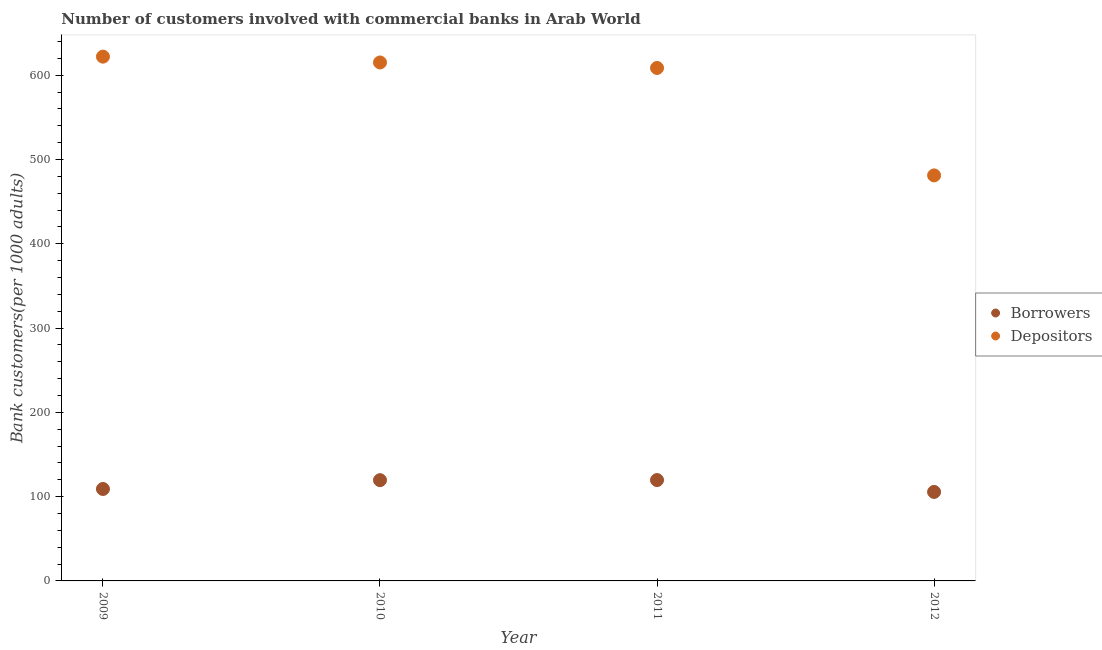Is the number of dotlines equal to the number of legend labels?
Ensure brevity in your answer.  Yes. What is the number of depositors in 2011?
Ensure brevity in your answer.  608.64. Across all years, what is the maximum number of borrowers?
Keep it short and to the point. 119.68. Across all years, what is the minimum number of borrowers?
Offer a terse response. 105.58. In which year was the number of borrowers maximum?
Provide a succinct answer. 2011. In which year was the number of borrowers minimum?
Make the answer very short. 2012. What is the total number of depositors in the graph?
Your answer should be compact. 2327.04. What is the difference between the number of depositors in 2011 and that in 2012?
Offer a terse response. 127.47. What is the difference between the number of depositors in 2012 and the number of borrowers in 2009?
Offer a terse response. 372.07. What is the average number of depositors per year?
Make the answer very short. 581.76. In the year 2009, what is the difference between the number of borrowers and number of depositors?
Provide a succinct answer. -512.98. What is the ratio of the number of depositors in 2011 to that in 2012?
Keep it short and to the point. 1.26. Is the difference between the number of borrowers in 2010 and 2012 greater than the difference between the number of depositors in 2010 and 2012?
Offer a terse response. No. What is the difference between the highest and the second highest number of depositors?
Your answer should be compact. 6.92. What is the difference between the highest and the lowest number of depositors?
Make the answer very short. 140.91. Does the number of borrowers monotonically increase over the years?
Ensure brevity in your answer.  No. Is the number of borrowers strictly greater than the number of depositors over the years?
Keep it short and to the point. No. Is the number of depositors strictly less than the number of borrowers over the years?
Your answer should be very brief. No. How many dotlines are there?
Provide a short and direct response. 2. How many years are there in the graph?
Your answer should be very brief. 4. What is the difference between two consecutive major ticks on the Y-axis?
Ensure brevity in your answer.  100. Does the graph contain any zero values?
Provide a succinct answer. No. How many legend labels are there?
Provide a short and direct response. 2. How are the legend labels stacked?
Ensure brevity in your answer.  Vertical. What is the title of the graph?
Make the answer very short. Number of customers involved with commercial banks in Arab World. Does "Non-resident workers" appear as one of the legend labels in the graph?
Keep it short and to the point. No. What is the label or title of the Y-axis?
Keep it short and to the point. Bank customers(per 1000 adults). What is the Bank customers(per 1000 adults) of Borrowers in 2009?
Provide a succinct answer. 109.1. What is the Bank customers(per 1000 adults) in Depositors in 2009?
Your answer should be compact. 622.08. What is the Bank customers(per 1000 adults) of Borrowers in 2010?
Give a very brief answer. 119.55. What is the Bank customers(per 1000 adults) in Depositors in 2010?
Provide a short and direct response. 615.16. What is the Bank customers(per 1000 adults) in Borrowers in 2011?
Keep it short and to the point. 119.68. What is the Bank customers(per 1000 adults) in Depositors in 2011?
Make the answer very short. 608.64. What is the Bank customers(per 1000 adults) of Borrowers in 2012?
Offer a very short reply. 105.58. What is the Bank customers(per 1000 adults) of Depositors in 2012?
Provide a short and direct response. 481.17. Across all years, what is the maximum Bank customers(per 1000 adults) of Borrowers?
Give a very brief answer. 119.68. Across all years, what is the maximum Bank customers(per 1000 adults) in Depositors?
Offer a terse response. 622.08. Across all years, what is the minimum Bank customers(per 1000 adults) of Borrowers?
Make the answer very short. 105.58. Across all years, what is the minimum Bank customers(per 1000 adults) in Depositors?
Make the answer very short. 481.17. What is the total Bank customers(per 1000 adults) in Borrowers in the graph?
Provide a short and direct response. 453.91. What is the total Bank customers(per 1000 adults) in Depositors in the graph?
Provide a short and direct response. 2327.04. What is the difference between the Bank customers(per 1000 adults) in Borrowers in 2009 and that in 2010?
Keep it short and to the point. -10.45. What is the difference between the Bank customers(per 1000 adults) of Depositors in 2009 and that in 2010?
Make the answer very short. 6.92. What is the difference between the Bank customers(per 1000 adults) of Borrowers in 2009 and that in 2011?
Ensure brevity in your answer.  -10.58. What is the difference between the Bank customers(per 1000 adults) of Depositors in 2009 and that in 2011?
Provide a short and direct response. 13.44. What is the difference between the Bank customers(per 1000 adults) in Borrowers in 2009 and that in 2012?
Your response must be concise. 3.52. What is the difference between the Bank customers(per 1000 adults) in Depositors in 2009 and that in 2012?
Ensure brevity in your answer.  140.91. What is the difference between the Bank customers(per 1000 adults) of Borrowers in 2010 and that in 2011?
Provide a short and direct response. -0.13. What is the difference between the Bank customers(per 1000 adults) of Depositors in 2010 and that in 2011?
Offer a very short reply. 6.52. What is the difference between the Bank customers(per 1000 adults) of Borrowers in 2010 and that in 2012?
Offer a very short reply. 13.97. What is the difference between the Bank customers(per 1000 adults) of Depositors in 2010 and that in 2012?
Ensure brevity in your answer.  133.99. What is the difference between the Bank customers(per 1000 adults) of Borrowers in 2011 and that in 2012?
Provide a succinct answer. 14.1. What is the difference between the Bank customers(per 1000 adults) of Depositors in 2011 and that in 2012?
Provide a succinct answer. 127.47. What is the difference between the Bank customers(per 1000 adults) in Borrowers in 2009 and the Bank customers(per 1000 adults) in Depositors in 2010?
Provide a short and direct response. -506.06. What is the difference between the Bank customers(per 1000 adults) of Borrowers in 2009 and the Bank customers(per 1000 adults) of Depositors in 2011?
Provide a short and direct response. -499.54. What is the difference between the Bank customers(per 1000 adults) of Borrowers in 2009 and the Bank customers(per 1000 adults) of Depositors in 2012?
Ensure brevity in your answer.  -372.07. What is the difference between the Bank customers(per 1000 adults) in Borrowers in 2010 and the Bank customers(per 1000 adults) in Depositors in 2011?
Provide a short and direct response. -489.09. What is the difference between the Bank customers(per 1000 adults) in Borrowers in 2010 and the Bank customers(per 1000 adults) in Depositors in 2012?
Give a very brief answer. -361.62. What is the difference between the Bank customers(per 1000 adults) of Borrowers in 2011 and the Bank customers(per 1000 adults) of Depositors in 2012?
Make the answer very short. -361.49. What is the average Bank customers(per 1000 adults) of Borrowers per year?
Offer a terse response. 113.48. What is the average Bank customers(per 1000 adults) of Depositors per year?
Offer a very short reply. 581.76. In the year 2009, what is the difference between the Bank customers(per 1000 adults) of Borrowers and Bank customers(per 1000 adults) of Depositors?
Keep it short and to the point. -512.98. In the year 2010, what is the difference between the Bank customers(per 1000 adults) in Borrowers and Bank customers(per 1000 adults) in Depositors?
Make the answer very short. -495.61. In the year 2011, what is the difference between the Bank customers(per 1000 adults) in Borrowers and Bank customers(per 1000 adults) in Depositors?
Provide a succinct answer. -488.96. In the year 2012, what is the difference between the Bank customers(per 1000 adults) in Borrowers and Bank customers(per 1000 adults) in Depositors?
Your answer should be compact. -375.59. What is the ratio of the Bank customers(per 1000 adults) in Borrowers in 2009 to that in 2010?
Offer a terse response. 0.91. What is the ratio of the Bank customers(per 1000 adults) in Depositors in 2009 to that in 2010?
Your response must be concise. 1.01. What is the ratio of the Bank customers(per 1000 adults) in Borrowers in 2009 to that in 2011?
Give a very brief answer. 0.91. What is the ratio of the Bank customers(per 1000 adults) of Depositors in 2009 to that in 2011?
Offer a terse response. 1.02. What is the ratio of the Bank customers(per 1000 adults) in Borrowers in 2009 to that in 2012?
Ensure brevity in your answer.  1.03. What is the ratio of the Bank customers(per 1000 adults) of Depositors in 2009 to that in 2012?
Provide a short and direct response. 1.29. What is the ratio of the Bank customers(per 1000 adults) of Depositors in 2010 to that in 2011?
Your response must be concise. 1.01. What is the ratio of the Bank customers(per 1000 adults) of Borrowers in 2010 to that in 2012?
Your response must be concise. 1.13. What is the ratio of the Bank customers(per 1000 adults) of Depositors in 2010 to that in 2012?
Provide a succinct answer. 1.28. What is the ratio of the Bank customers(per 1000 adults) in Borrowers in 2011 to that in 2012?
Your response must be concise. 1.13. What is the ratio of the Bank customers(per 1000 adults) in Depositors in 2011 to that in 2012?
Provide a succinct answer. 1.26. What is the difference between the highest and the second highest Bank customers(per 1000 adults) of Borrowers?
Ensure brevity in your answer.  0.13. What is the difference between the highest and the second highest Bank customers(per 1000 adults) of Depositors?
Your answer should be compact. 6.92. What is the difference between the highest and the lowest Bank customers(per 1000 adults) in Borrowers?
Your answer should be compact. 14.1. What is the difference between the highest and the lowest Bank customers(per 1000 adults) of Depositors?
Ensure brevity in your answer.  140.91. 